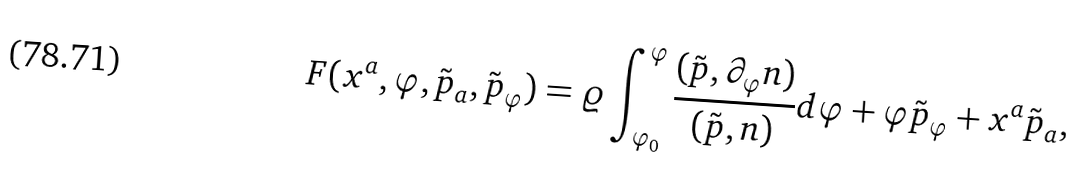<formula> <loc_0><loc_0><loc_500><loc_500>F ( x ^ { a } , \varphi , \tilde { p } _ { a } , \tilde { p } _ { \varphi } ) = \varrho \int _ { \varphi _ { 0 } } ^ { \varphi } \frac { ( \tilde { p } , \partial _ { \varphi } n ) } { ( \tilde { p } , n ) } d \varphi + \varphi \tilde { p } _ { \varphi } + x ^ { a } \tilde { p } _ { a } ,</formula> 